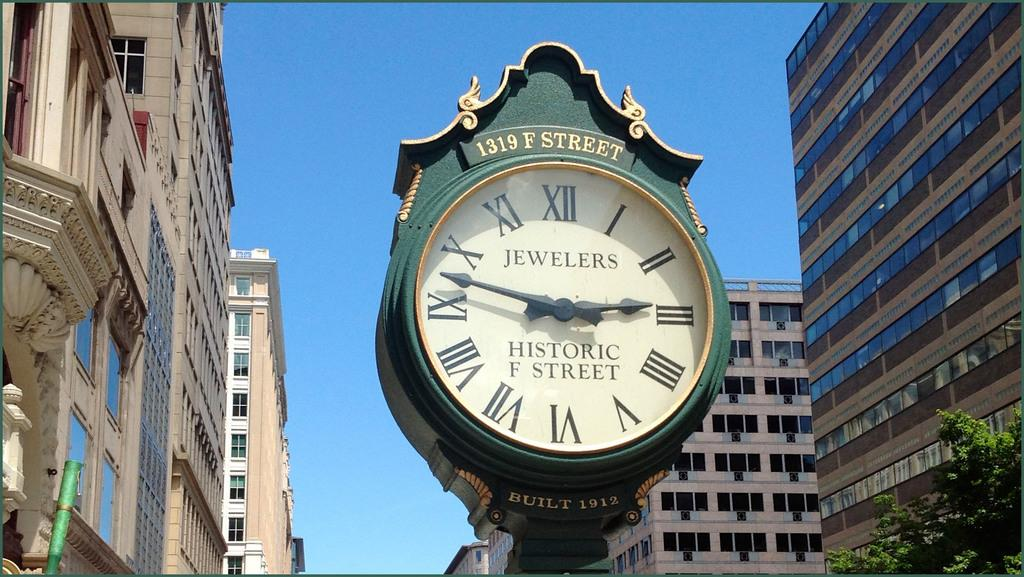<image>
Present a compact description of the photo's key features. a clock that has 1 to 12 on it 